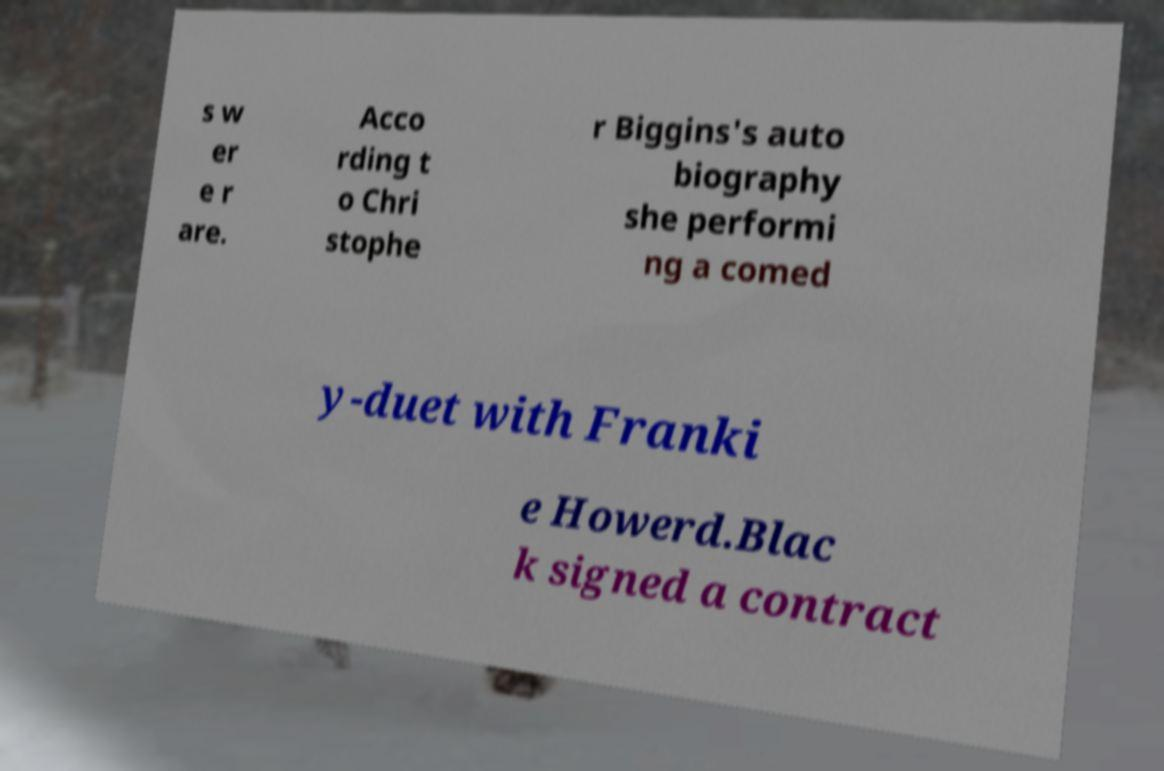What messages or text are displayed in this image? I need them in a readable, typed format. s w er e r are. Acco rding t o Chri stophe r Biggins's auto biography she performi ng a comed y-duet with Franki e Howerd.Blac k signed a contract 